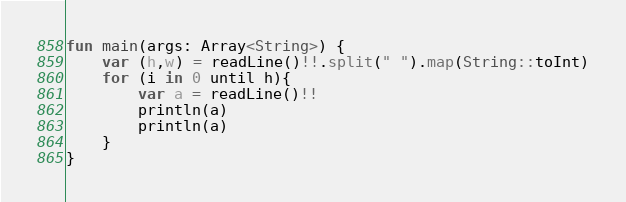Convert code to text. <code><loc_0><loc_0><loc_500><loc_500><_Kotlin_>fun main(args: Array<String>) {
    var (h,w) = readLine()!!.split(" ").map(String::toInt)
    for (i in 0 until h){
        var a = readLine()!!
        println(a)
        println(a)
    }
}</code> 